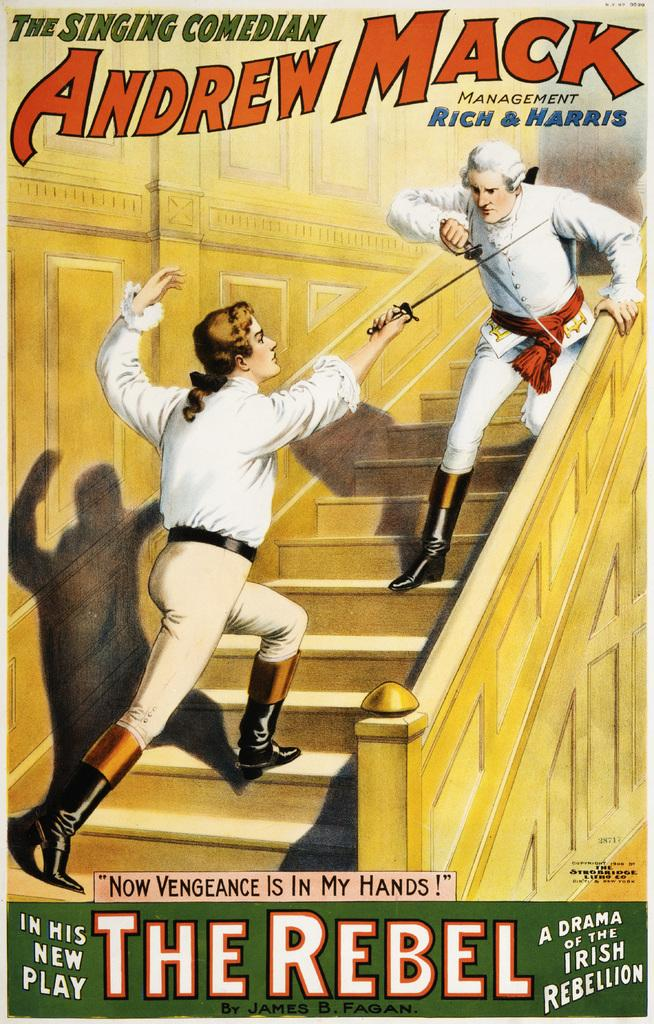<image>
Share a concise interpretation of the image provided. a poster that says 'the singing comedian andrew mack' on it 